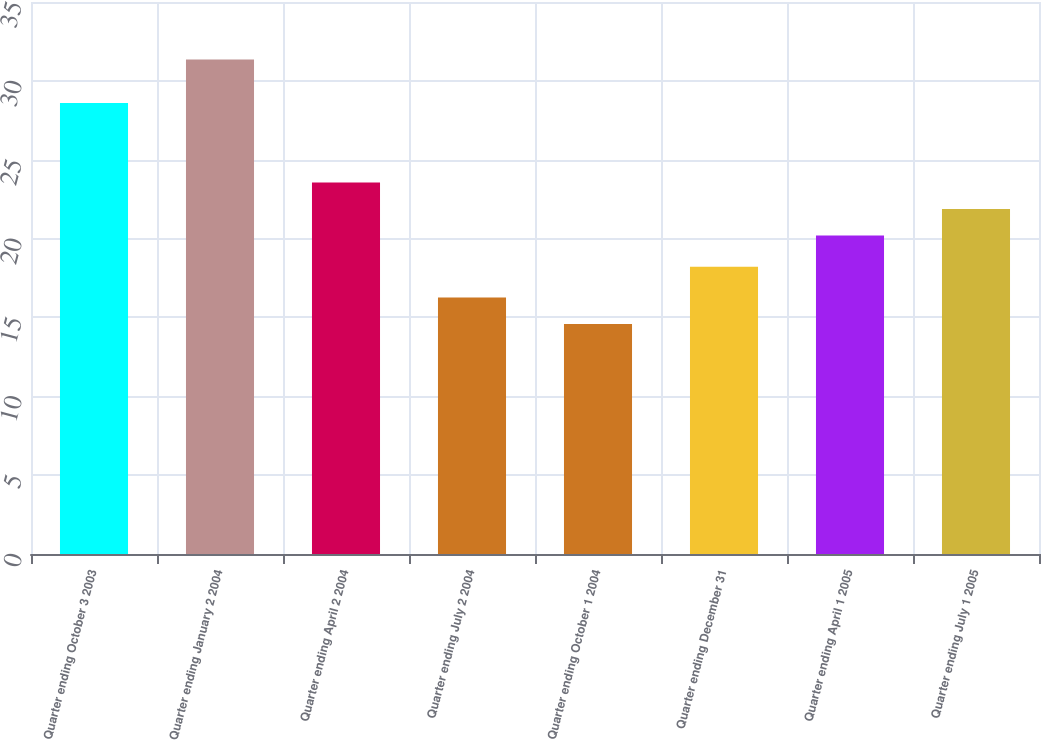Convert chart. <chart><loc_0><loc_0><loc_500><loc_500><bar_chart><fcel>Quarter ending October 3 2003<fcel>Quarter ending January 2 2004<fcel>Quarter ending April 2 2004<fcel>Quarter ending July 2 2004<fcel>Quarter ending October 1 2004<fcel>Quarter ending December 31<fcel>Quarter ending April 1 2005<fcel>Quarter ending July 1 2005<nl><fcel>28.6<fcel>31.35<fcel>23.56<fcel>16.27<fcel>14.59<fcel>18.21<fcel>20.2<fcel>21.88<nl></chart> 